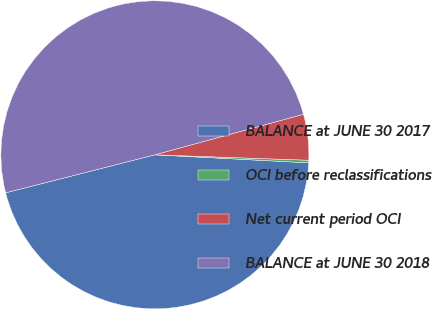Convert chart. <chart><loc_0><loc_0><loc_500><loc_500><pie_chart><fcel>BALANCE at JUNE 30 2017<fcel>OCI before reclassifications<fcel>Net current period OCI<fcel>BALANCE at JUNE 30 2018<nl><fcel>45.2%<fcel>0.27%<fcel>4.8%<fcel>49.73%<nl></chart> 